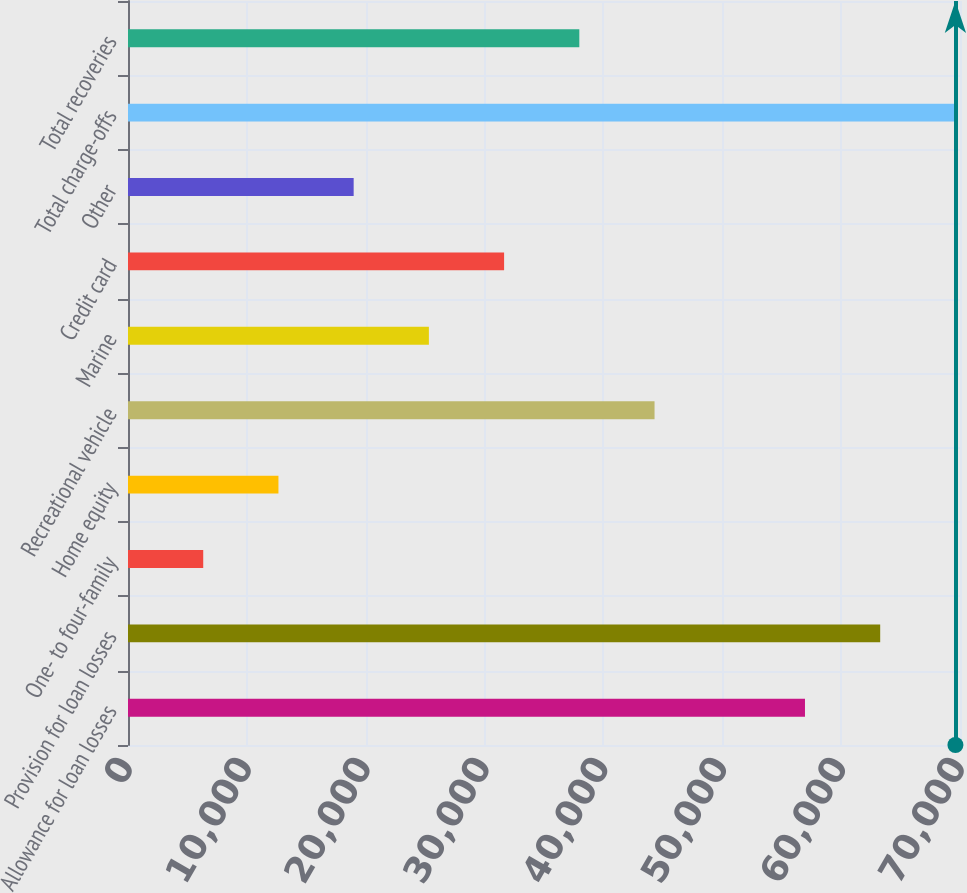Convert chart. <chart><loc_0><loc_0><loc_500><loc_500><bar_chart><fcel>Allowance for loan losses<fcel>Provision for loan losses<fcel>One- to four-family<fcel>Home equity<fcel>Recreational vehicle<fcel>Marine<fcel>Credit card<fcel>Other<fcel>Total charge-offs<fcel>Total recoveries<nl><fcel>56957.4<fcel>63286<fcel>6328.83<fcel>12657.4<fcel>44300.2<fcel>25314.5<fcel>31643.1<fcel>18986<fcel>69614.5<fcel>37971.7<nl></chart> 